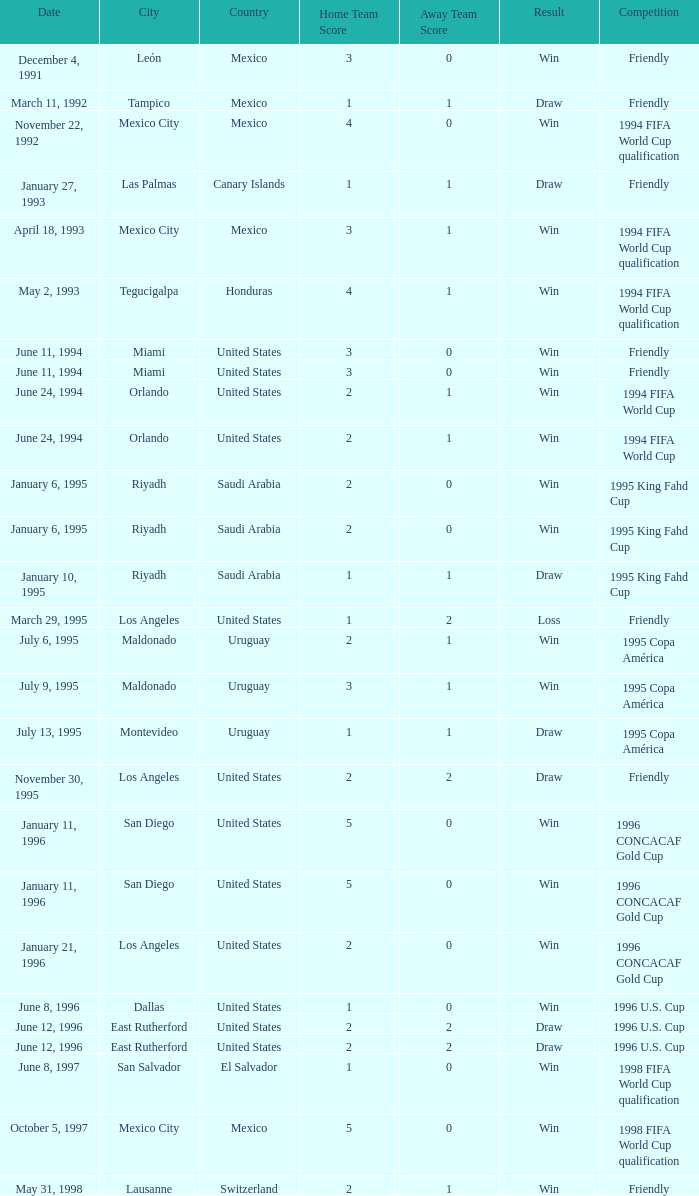What is Score, when Date is "June 8, 1996"? 1–0. 